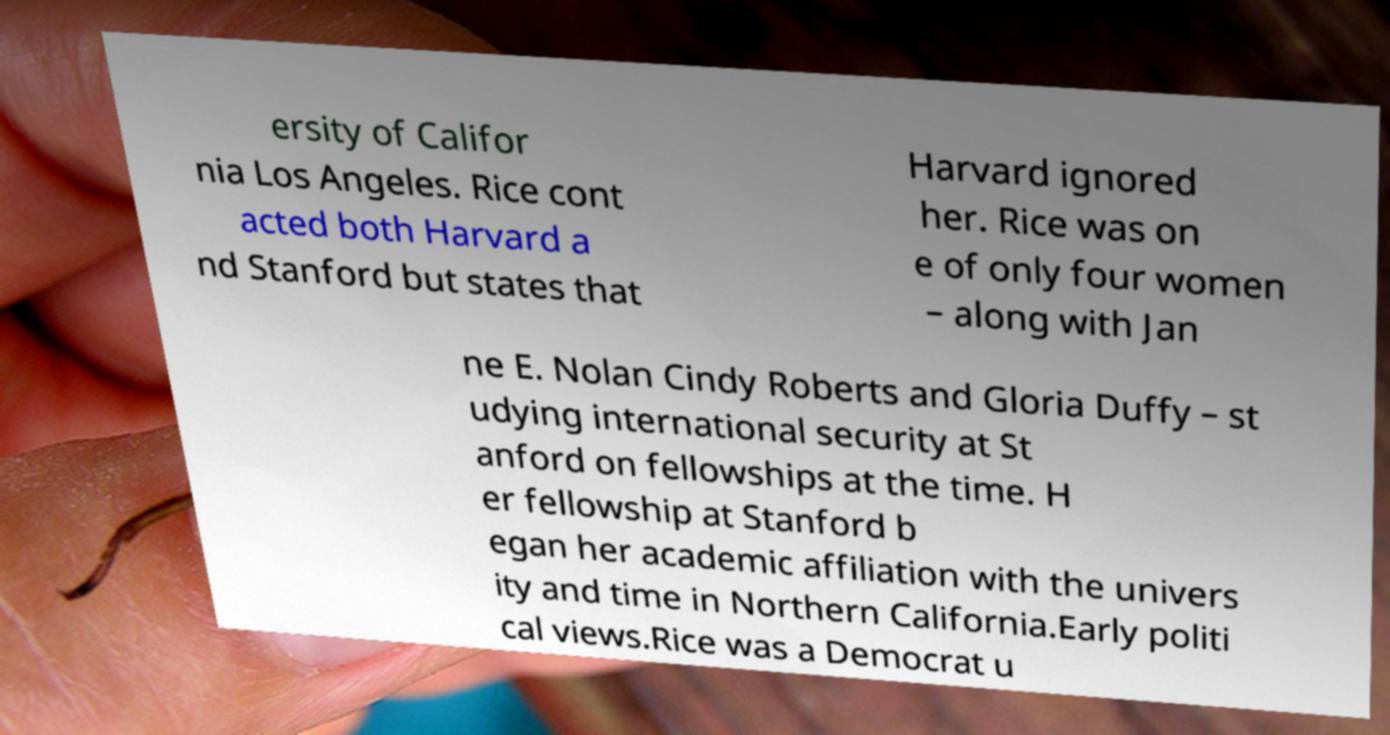What messages or text are displayed in this image? I need them in a readable, typed format. ersity of Califor nia Los Angeles. Rice cont acted both Harvard a nd Stanford but states that Harvard ignored her. Rice was on e of only four women – along with Jan ne E. Nolan Cindy Roberts and Gloria Duffy – st udying international security at St anford on fellowships at the time. H er fellowship at Stanford b egan her academic affiliation with the univers ity and time in Northern California.Early politi cal views.Rice was a Democrat u 